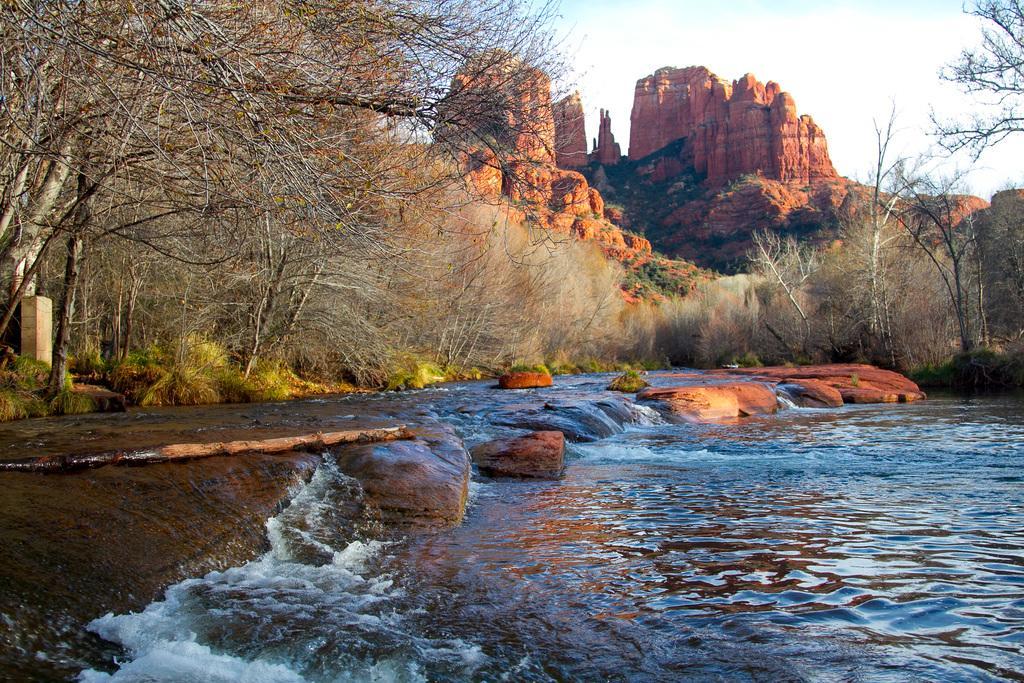How would you summarize this image in a sentence or two? In this image, we can see the water, there are some trees and we can see the rocks, at the top there is a sky. 